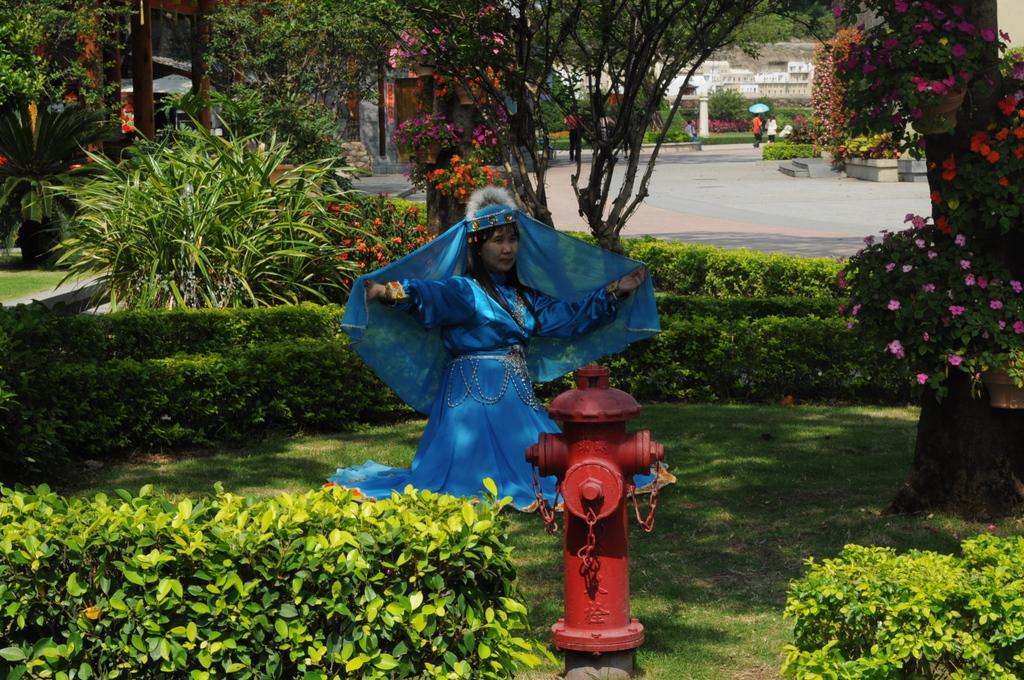Describe this image in one or two sentences. At the bottom, we see the shrubs, grass and an iron rod. In the middle, we see a woman in the blue dress is posing for the photo. On the right side, we see the plants and the flowertots which have flowers. These flowers are in pink, orange and red color. Behind her, we see the trees and the plants. On the left side, we see the plants and the flowers in orange, red and pink color. There are trees and the buildings in the background. We see two people are walking on the road. 